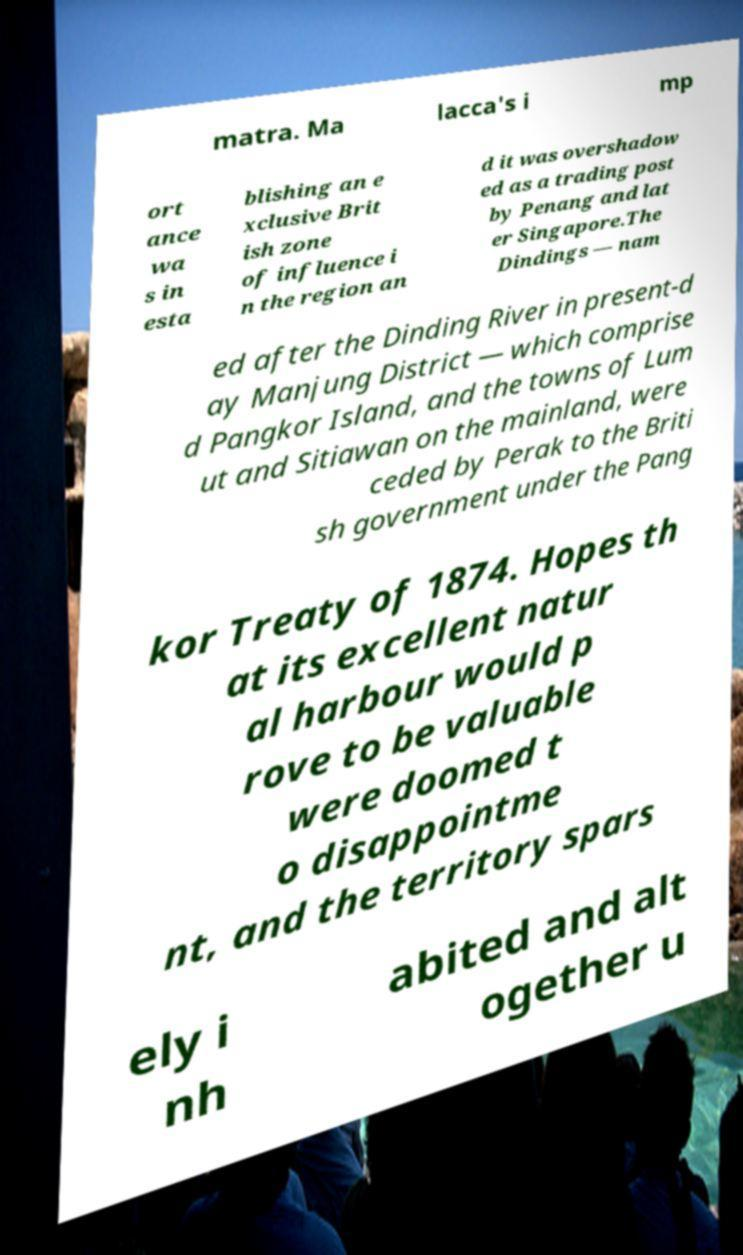Please read and relay the text visible in this image. What does it say? matra. Ma lacca's i mp ort ance wa s in esta blishing an e xclusive Brit ish zone of influence i n the region an d it was overshadow ed as a trading post by Penang and lat er Singapore.The Dindings — nam ed after the Dinding River in present-d ay Manjung District — which comprise d Pangkor Island, and the towns of Lum ut and Sitiawan on the mainland, were ceded by Perak to the Briti sh government under the Pang kor Treaty of 1874. Hopes th at its excellent natur al harbour would p rove to be valuable were doomed t o disappointme nt, and the territory spars ely i nh abited and alt ogether u 